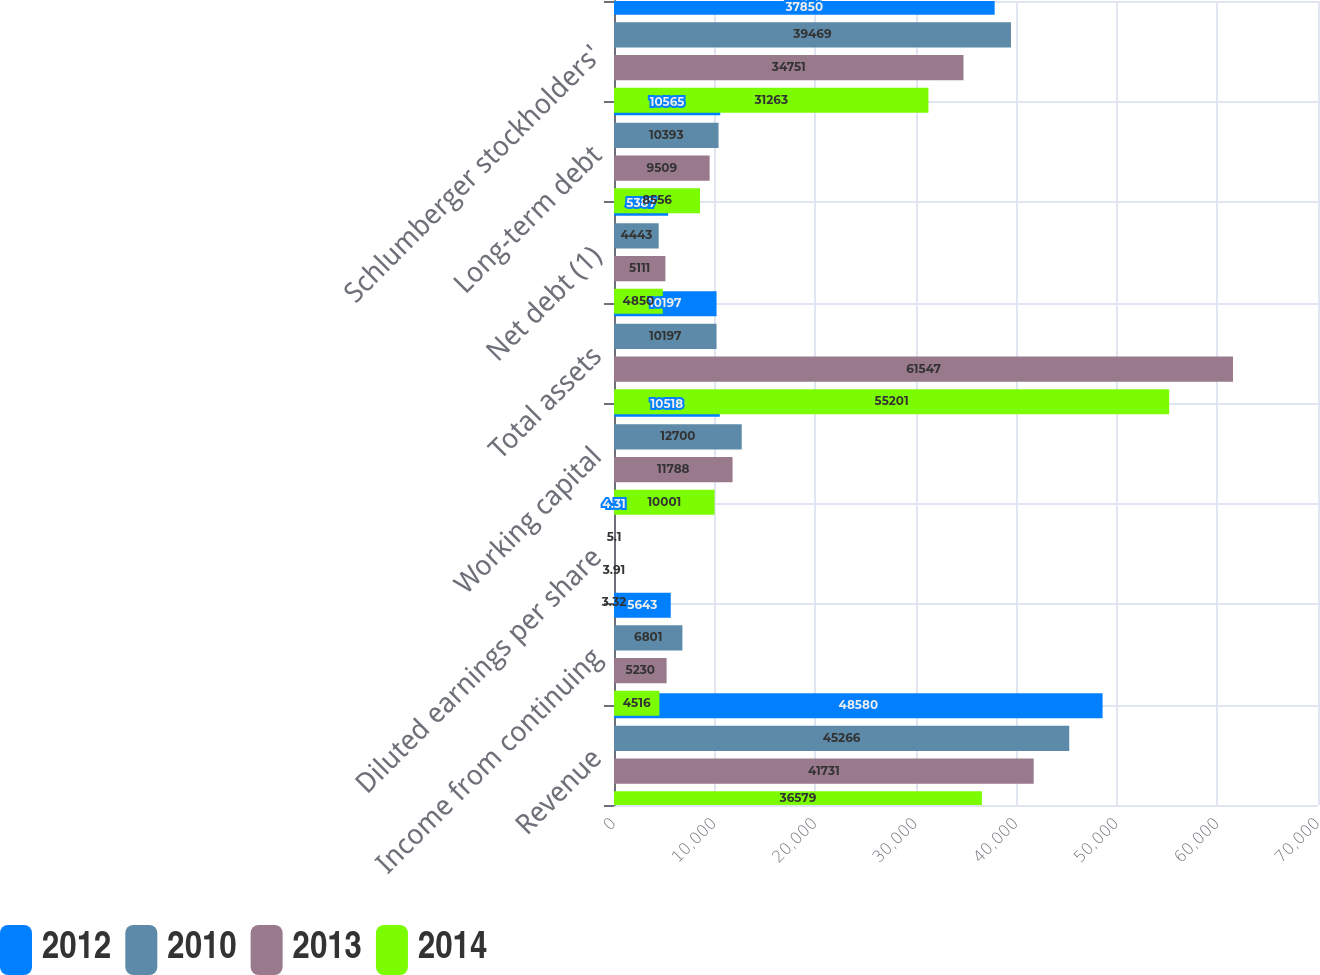<chart> <loc_0><loc_0><loc_500><loc_500><stacked_bar_chart><ecel><fcel>Revenue<fcel>Income from continuing<fcel>Diluted earnings per share<fcel>Working capital<fcel>Total assets<fcel>Net debt (1)<fcel>Long-term debt<fcel>Schlumberger stockholders'<nl><fcel>2012<fcel>48580<fcel>5643<fcel>4.31<fcel>10518<fcel>10197<fcel>5387<fcel>10565<fcel>37850<nl><fcel>2010<fcel>45266<fcel>6801<fcel>5.1<fcel>12700<fcel>10197<fcel>4443<fcel>10393<fcel>39469<nl><fcel>2013<fcel>41731<fcel>5230<fcel>3.91<fcel>11788<fcel>61547<fcel>5111<fcel>9509<fcel>34751<nl><fcel>2014<fcel>36579<fcel>4516<fcel>3.32<fcel>10001<fcel>55201<fcel>4850<fcel>8556<fcel>31263<nl></chart> 